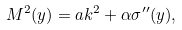<formula> <loc_0><loc_0><loc_500><loc_500>M ^ { 2 } ( y ) = a k ^ { 2 } + \alpha \sigma ^ { \prime \prime } ( y ) ,</formula> 